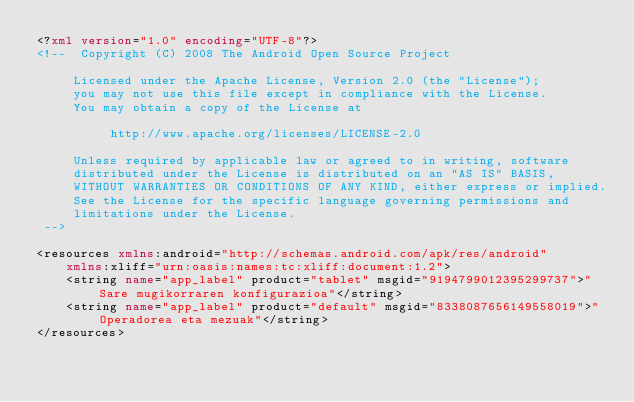<code> <loc_0><loc_0><loc_500><loc_500><_XML_><?xml version="1.0" encoding="UTF-8"?>
<!--  Copyright (C) 2008 The Android Open Source Project

     Licensed under the Apache License, Version 2.0 (the "License");
     you may not use this file except in compliance with the License.
     You may obtain a copy of the License at

          http://www.apache.org/licenses/LICENSE-2.0

     Unless required by applicable law or agreed to in writing, software
     distributed under the License is distributed on an "AS IS" BASIS,
     WITHOUT WARRANTIES OR CONDITIONS OF ANY KIND, either express or implied.
     See the License for the specific language governing permissions and
     limitations under the License.
 -->

<resources xmlns:android="http://schemas.android.com/apk/res/android"
    xmlns:xliff="urn:oasis:names:tc:xliff:document:1.2">
    <string name="app_label" product="tablet" msgid="9194799012395299737">"Sare mugikorraren konfigurazioa"</string>
    <string name="app_label" product="default" msgid="8338087656149558019">"Operadorea eta mezuak"</string>
</resources>
</code> 